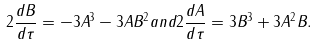Convert formula to latex. <formula><loc_0><loc_0><loc_500><loc_500>2 \frac { d B } { d \tau } = - 3 A ^ { 3 } - 3 A B ^ { 2 } a n d 2 \frac { d A } { d \tau } = 3 B ^ { 3 } + 3 A ^ { 2 } B .</formula> 